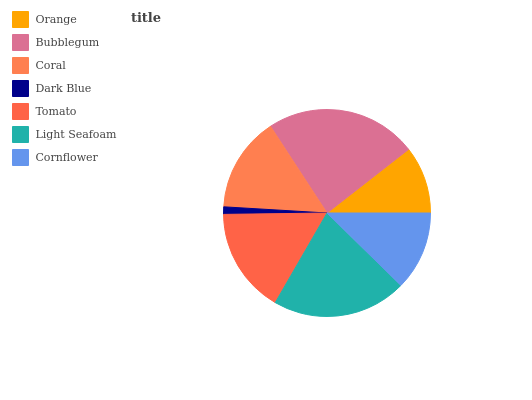Is Dark Blue the minimum?
Answer yes or no. Yes. Is Bubblegum the maximum?
Answer yes or no. Yes. Is Coral the minimum?
Answer yes or no. No. Is Coral the maximum?
Answer yes or no. No. Is Bubblegum greater than Coral?
Answer yes or no. Yes. Is Coral less than Bubblegum?
Answer yes or no. Yes. Is Coral greater than Bubblegum?
Answer yes or no. No. Is Bubblegum less than Coral?
Answer yes or no. No. Is Coral the high median?
Answer yes or no. Yes. Is Coral the low median?
Answer yes or no. Yes. Is Dark Blue the high median?
Answer yes or no. No. Is Tomato the low median?
Answer yes or no. No. 